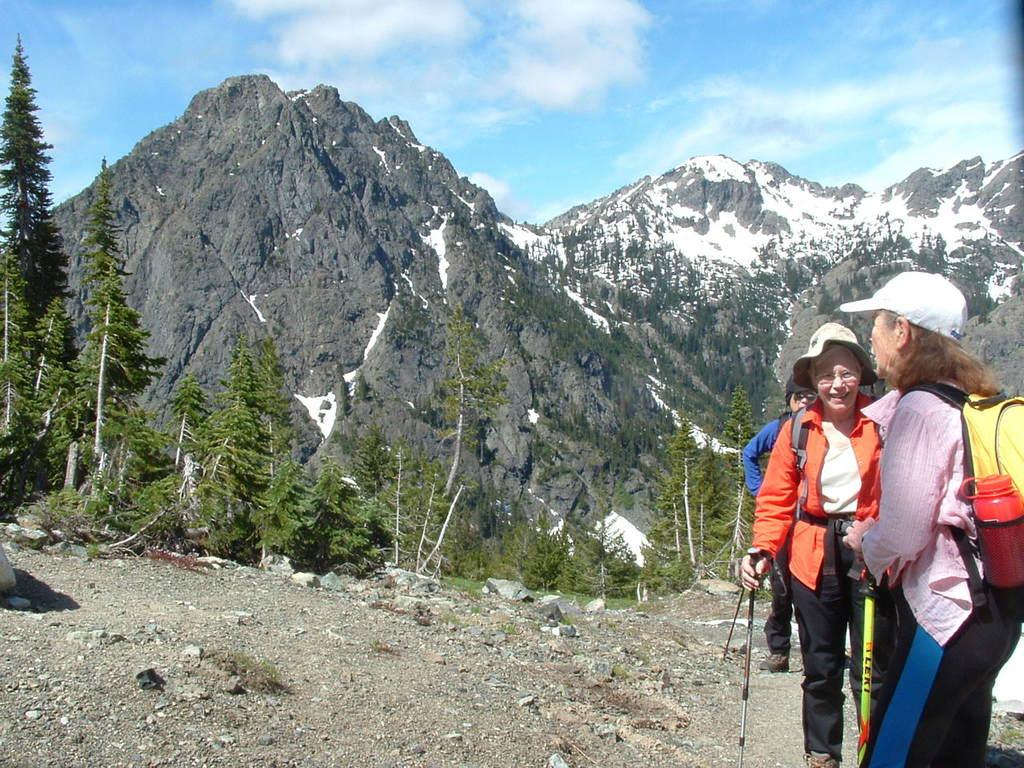What can be seen in the image? There are persons standing in the image, along with trees, a mountain, and the sky. Can you describe the landscape in the image? The landscape includes trees and a mountain. What is visible in the background of the image? The sky is visible in the background of the image. How many quarters can be seen on the persons' hands in the image? There are no quarters visible on the persons' hands in the image. What type of light is being used to draw the attention of the persons in the image? There is no mention of any light source or attention-grabbing element in the image. 